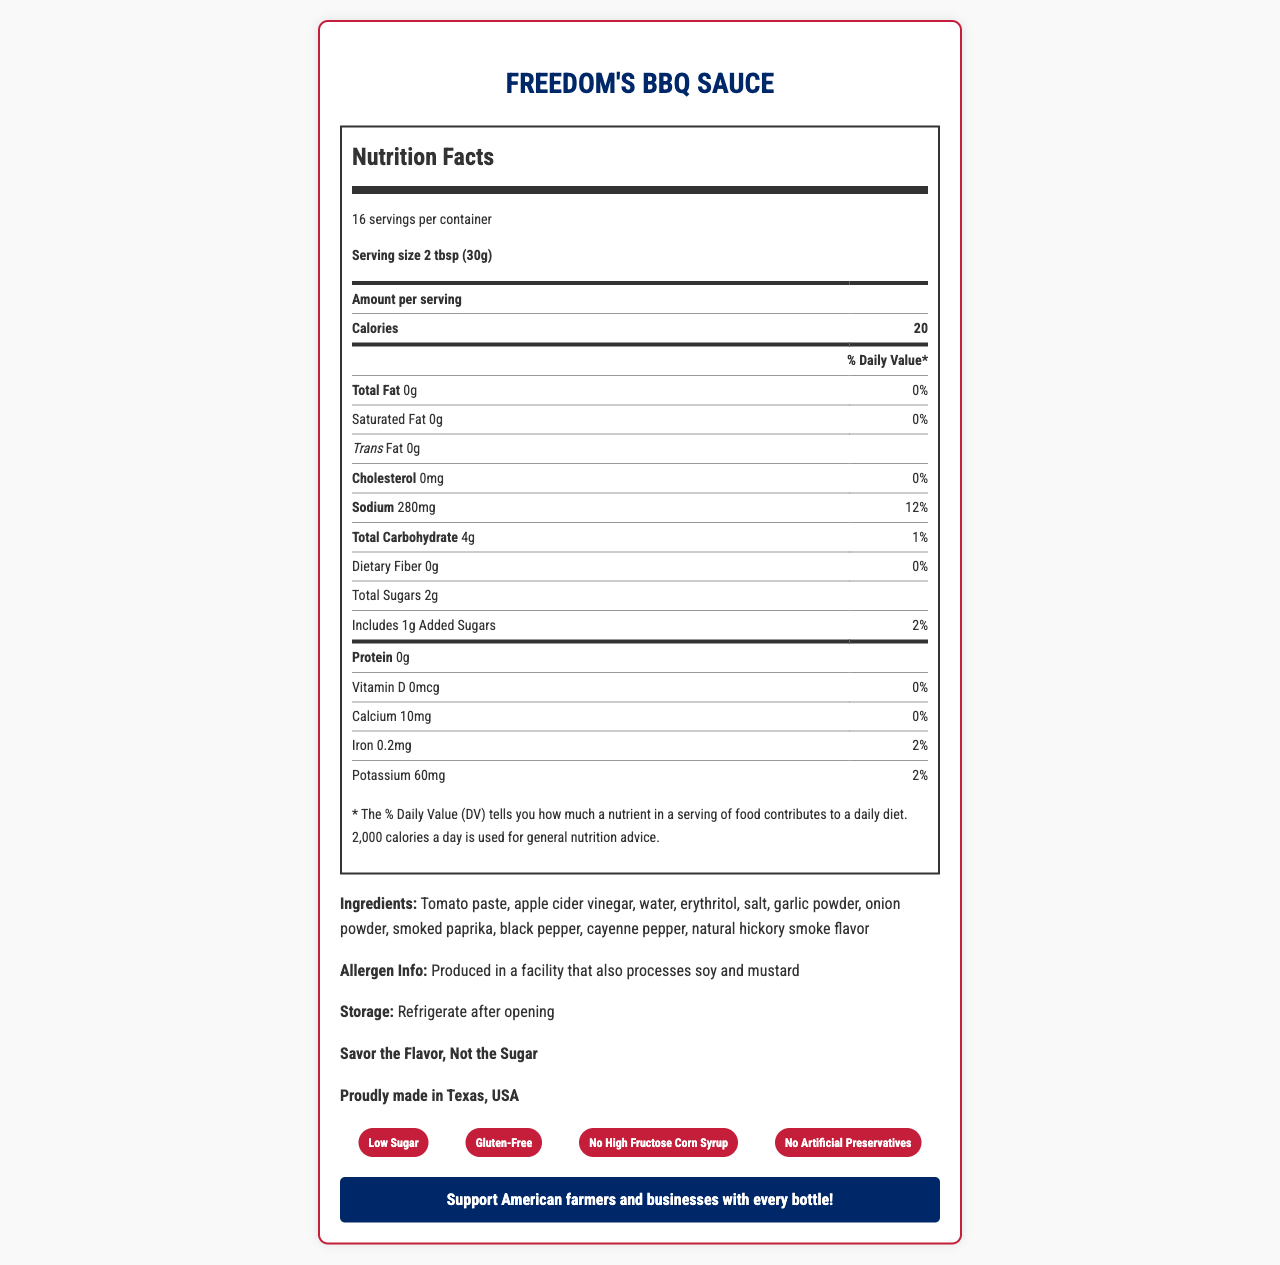what is the serving size for Freedom's BBQ Sauce? The serving size is mentioned at the start of the document under the product name.
Answer: 2 tbsp (30g) how many calories are there per serving? The calories per serving are listed in the nutrition facts section.
Answer: 20 what percentage of daily value (DV) of sodium is in each serving? The sodium content and its % Daily Value are listed in the nutrition facts section.
Answer: 12% what is the total amount of sugars per serving? The total sugars per serving are listed under the total carbohydrate section in the nutrition facts.
Answer: 2g how much added sugar is in each serving? The amount of added sugars per serving is listed under the total sugars section.
Answer: 1g which claims are made about the product? A. Low Sugar B. High Fiber C. Gluten-Free D. Made with Artificial Preservatives The certified claims section mentions "Low Sugar" and "Gluten-Free."
Answer: A and C how many servings are in the container? A. 10 B. 12 C. 14 D. 16 The number of servings per container is mentioned as 16 in the nutrition facts section.
Answer: D is Freedom's BBQ Sauce made in the United States? The document states it is "Proudly made in Texas, USA."
Answer: Yes are there any vitamins listed in the nutrition facts? Vitamin D is listed, although the amount is 0mcg.
Answer: Yes briefly summarize the document. The summary captures the main points of the document, describing the nutrition facts, ingredients, claims, and additional information provided.
Answer: The document provides detailed nutrition facts for Freedom's BBQ Sauce, emphasizing its low calorie and low sugar content. It includes a breakdown of nutrients per serving, a list of ingredients, allergen information, storage instructions, brand slogan, and patriotic message. The document also highlights that the sauce is gluten-free and contains no high fructose corn syrup or artificial preservatives. where is the ingredient erythritol placed in the list of ingredients? The ingredients are listed as "Tomato paste, apple cider vinegar, water, erythritol, salt, garlic powder, onion powder, smoked paprika, black pepper, cayenne pepper, natural hickory smoke flavor."
Answer: After water how much calcium is in each serving? The amount of calcium per serving is listed in the nutrition facts section.
Answer: 10mg can the presence of mustard be confirmed in the ingredients? The document states that it is produced in a facility that processes mustard but doesn't confirm if mustard is an ingredient in the product itself.
Answer: Not enough information what is the storage instruction for the sauce? The storage instruction is listed near the end of the document.
Answer: Refrigerate after opening does the product contain any dietary fiber? The dietary fiber amount is listed as 0g in the nutrition facts section.
Answer: No how much iron is in each serving? The amount of iron per serving is listed in the nutrition facts section.
Answer: 0.2mg is there any cholesterol in Freedom's BBQ Sauce? The cholesterol amount is listed as 0mg in the nutrition facts section.
Answer: No which seasoning is listed last in the ingredients? The last ingredient listed is natural hickory smoke flavor.
Answer: Natural hickory smoke flavor 